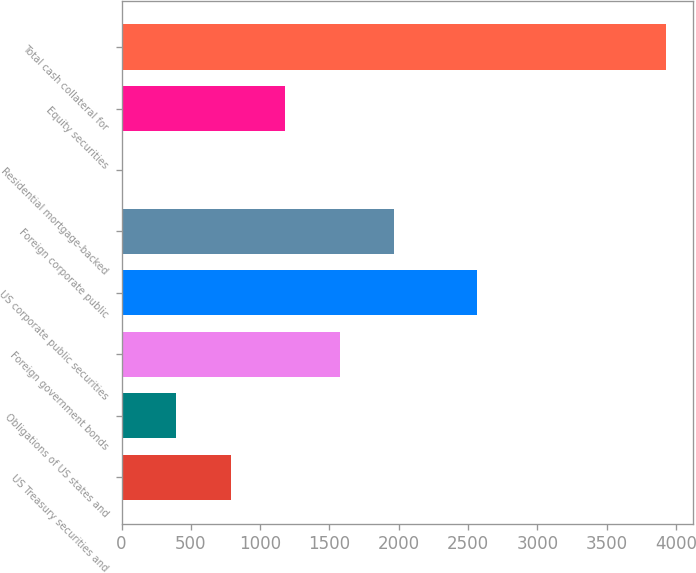Convert chart to OTSL. <chart><loc_0><loc_0><loc_500><loc_500><bar_chart><fcel>US Treasury securities and<fcel>Obligations of US states and<fcel>Foreign government bonds<fcel>US corporate public securities<fcel>Foreign corporate public<fcel>Residential mortgage-backed<fcel>Equity securities<fcel>Total cash collateral for<nl><fcel>787.53<fcel>394.85<fcel>1572.89<fcel>2563<fcel>1965.57<fcel>2.17<fcel>1180.21<fcel>3929<nl></chart> 